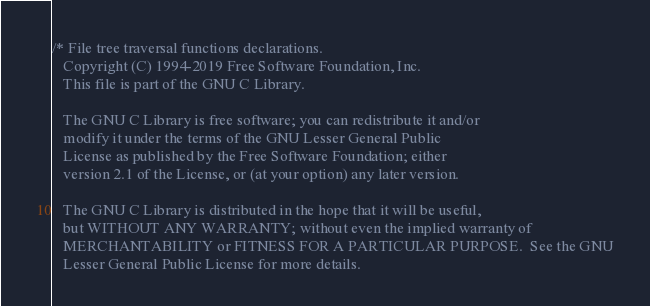Convert code to text. <code><loc_0><loc_0><loc_500><loc_500><_C_>/* File tree traversal functions declarations.
   Copyright (C) 1994-2019 Free Software Foundation, Inc.
   This file is part of the GNU C Library.

   The GNU C Library is free software; you can redistribute it and/or
   modify it under the terms of the GNU Lesser General Public
   License as published by the Free Software Foundation; either
   version 2.1 of the License, or (at your option) any later version.

   The GNU C Library is distributed in the hope that it will be useful,
   but WITHOUT ANY WARRANTY; without even the implied warranty of
   MERCHANTABILITY or FITNESS FOR A PARTICULAR PURPOSE.  See the GNU
   Lesser General Public License for more details.
</code> 